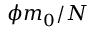<formula> <loc_0><loc_0><loc_500><loc_500>\phi m _ { 0 } / N</formula> 